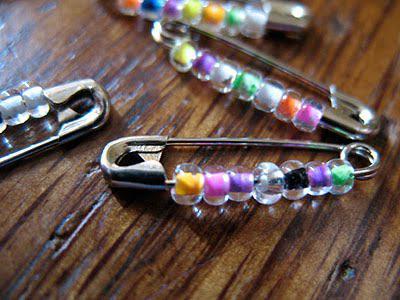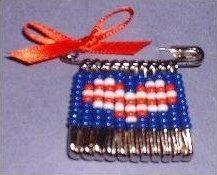The first image is the image on the left, the second image is the image on the right. Examine the images to the left and right. Is the description "The left image has four safety pins." accurate? Answer yes or no. Yes. The first image is the image on the left, the second image is the image on the right. Given the left and right images, does the statement "An image shows exactly six safety pins strung with beads, displayed on purple." hold true? Answer yes or no. No. 